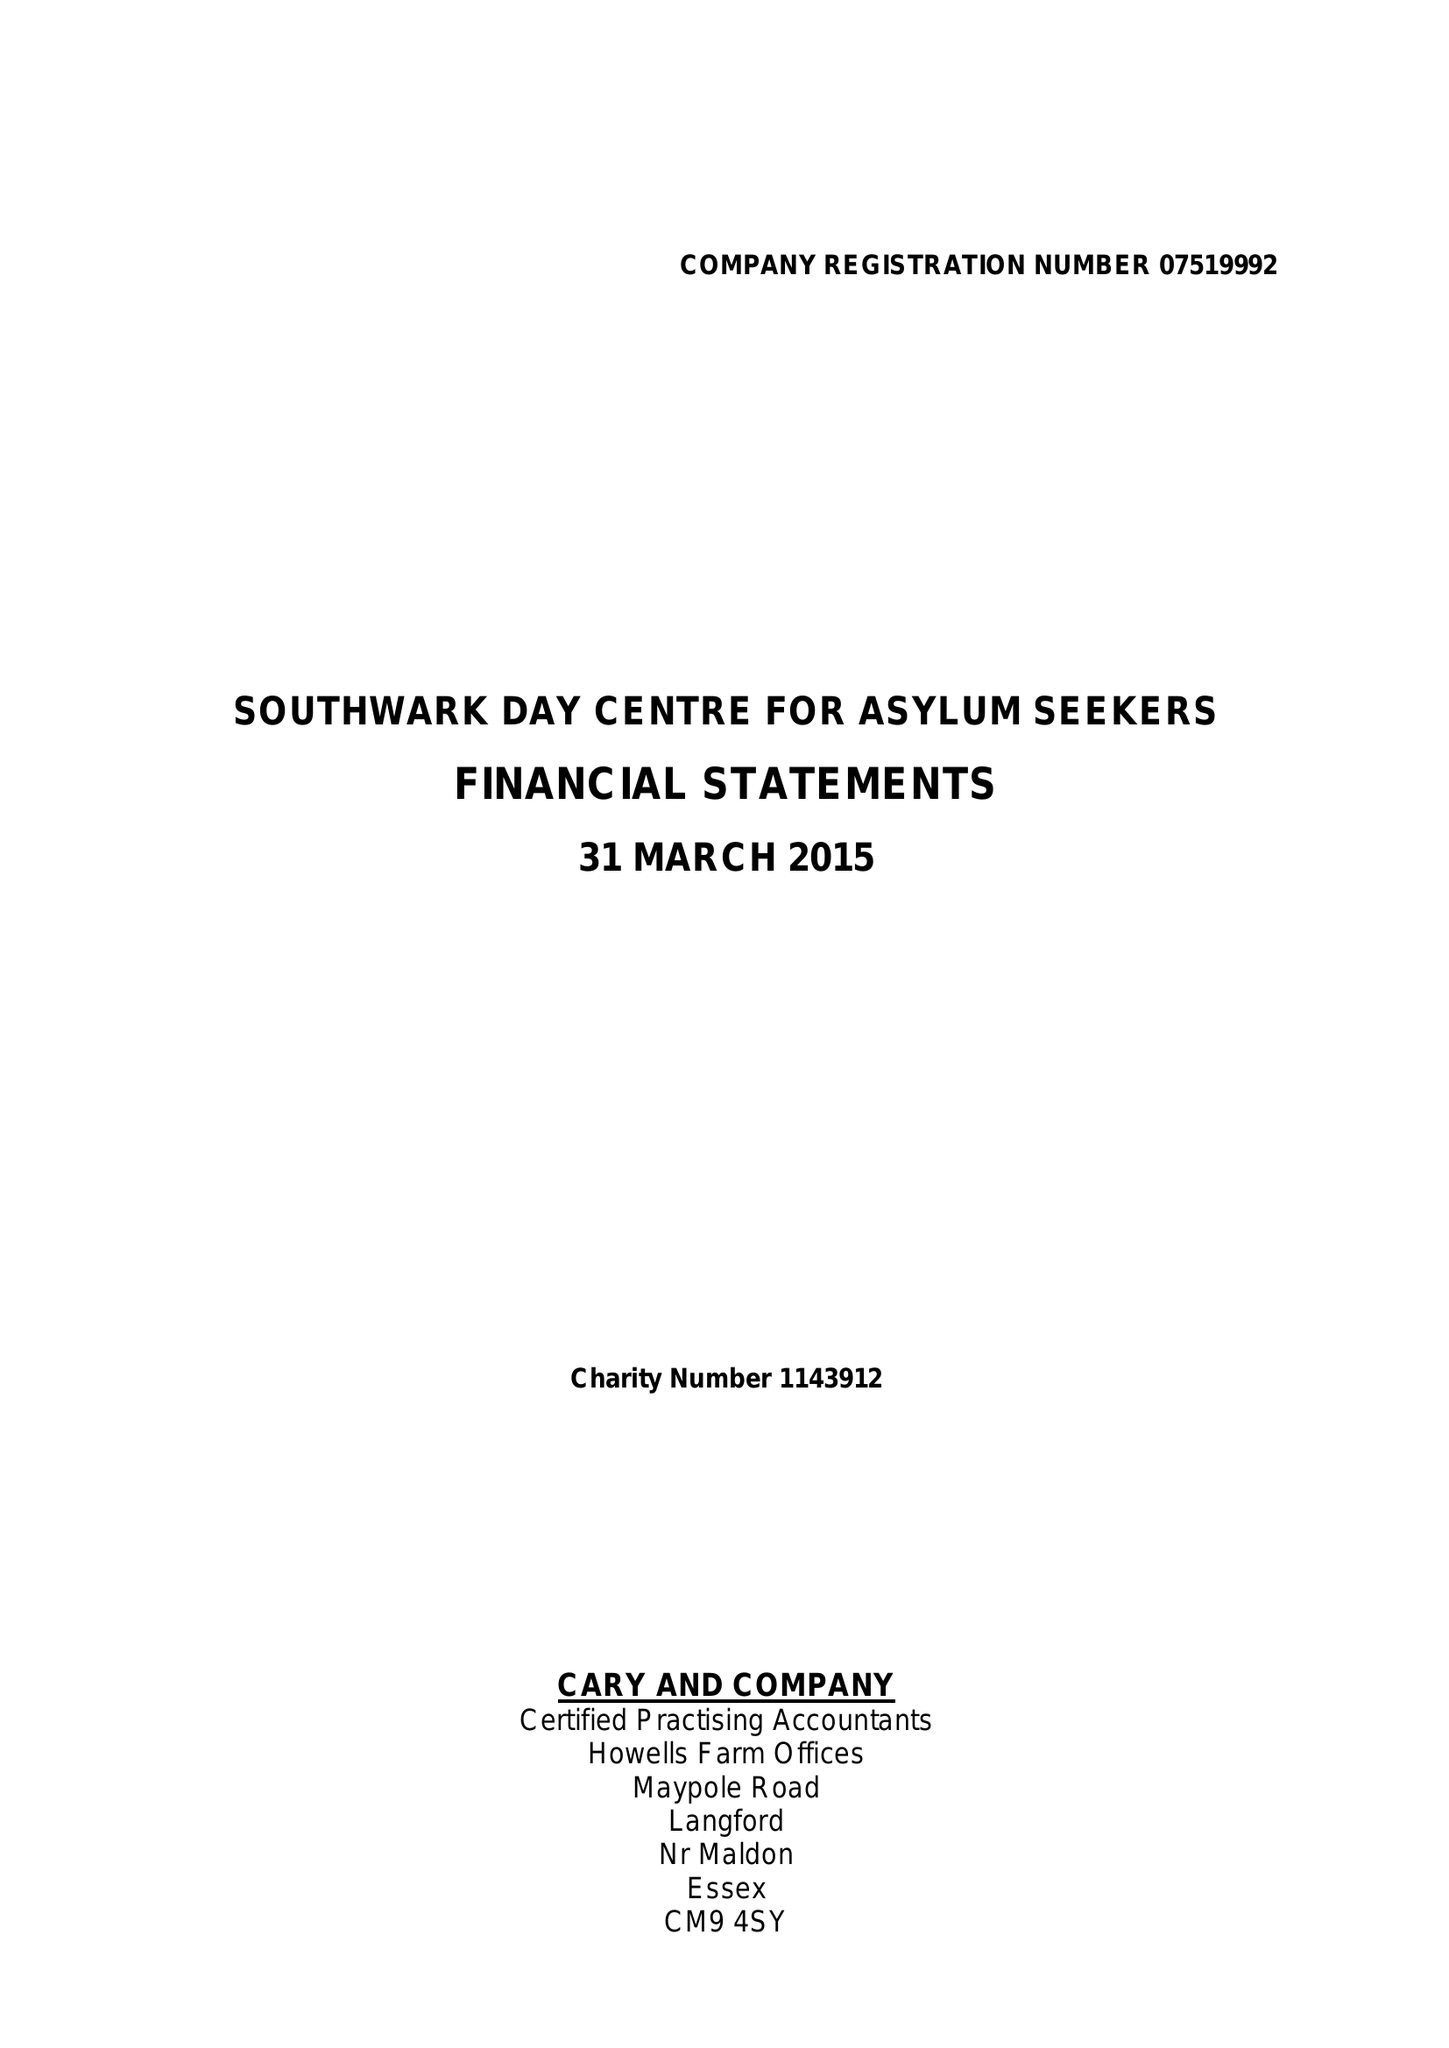What is the value for the spending_annually_in_british_pounds?
Answer the question using a single word or phrase. 186302.00 